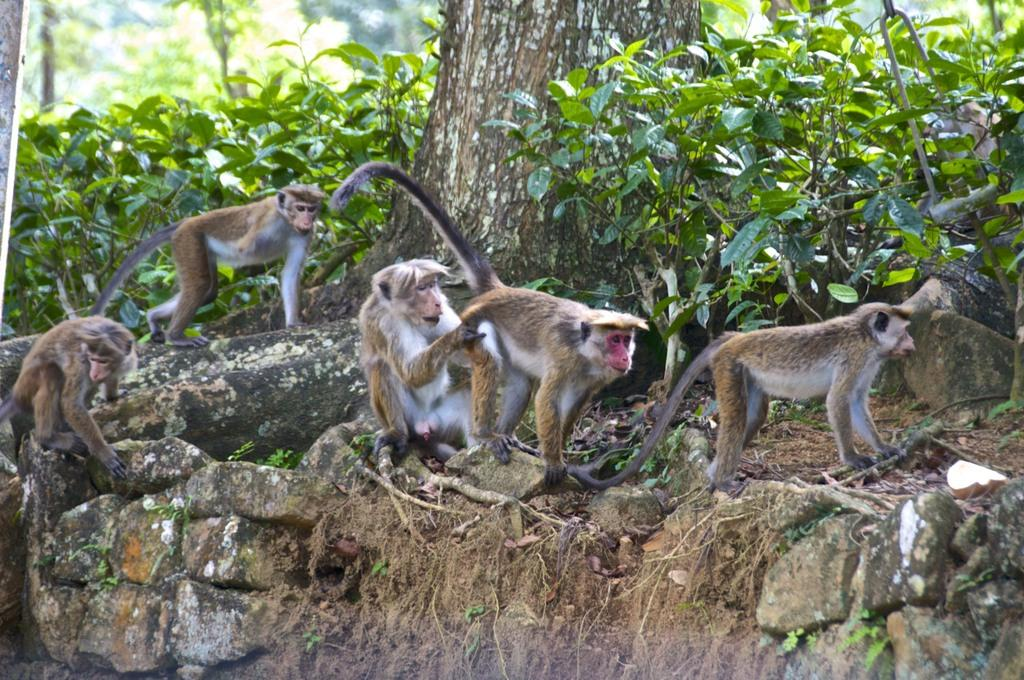What animals can be seen in the image? There are monkeys on the rocks in the image. What type of vegetation is present in the image? There are plants and trees in the image. How would you describe the background of the image? The background of the image is blurred. How many bikes are parked near the monkeys in the image? There are no bikes present in the image. What type of scale is used to weigh the monkeys in the image? There is no scale present in the image, and the monkeys are not being weighed. 